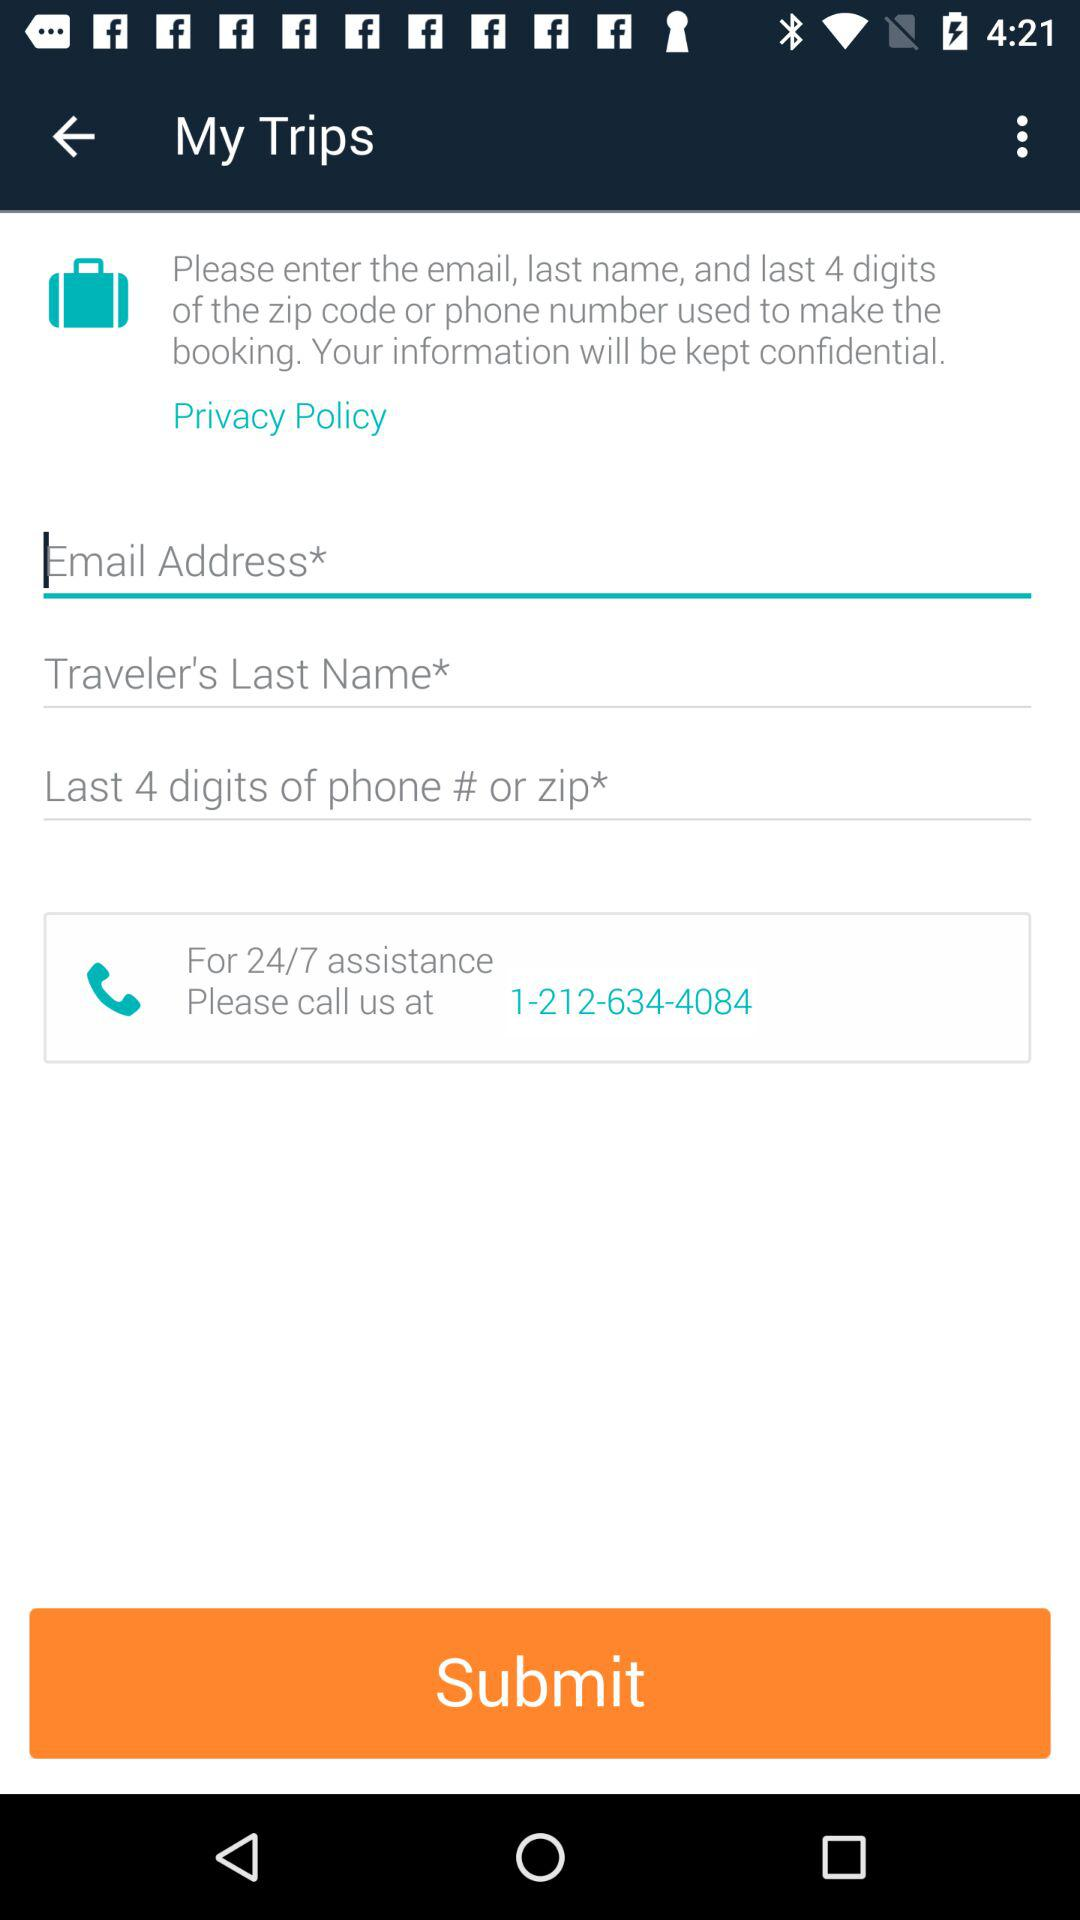How many text inputs are required to submit the form?
Answer the question using a single word or phrase. 3 